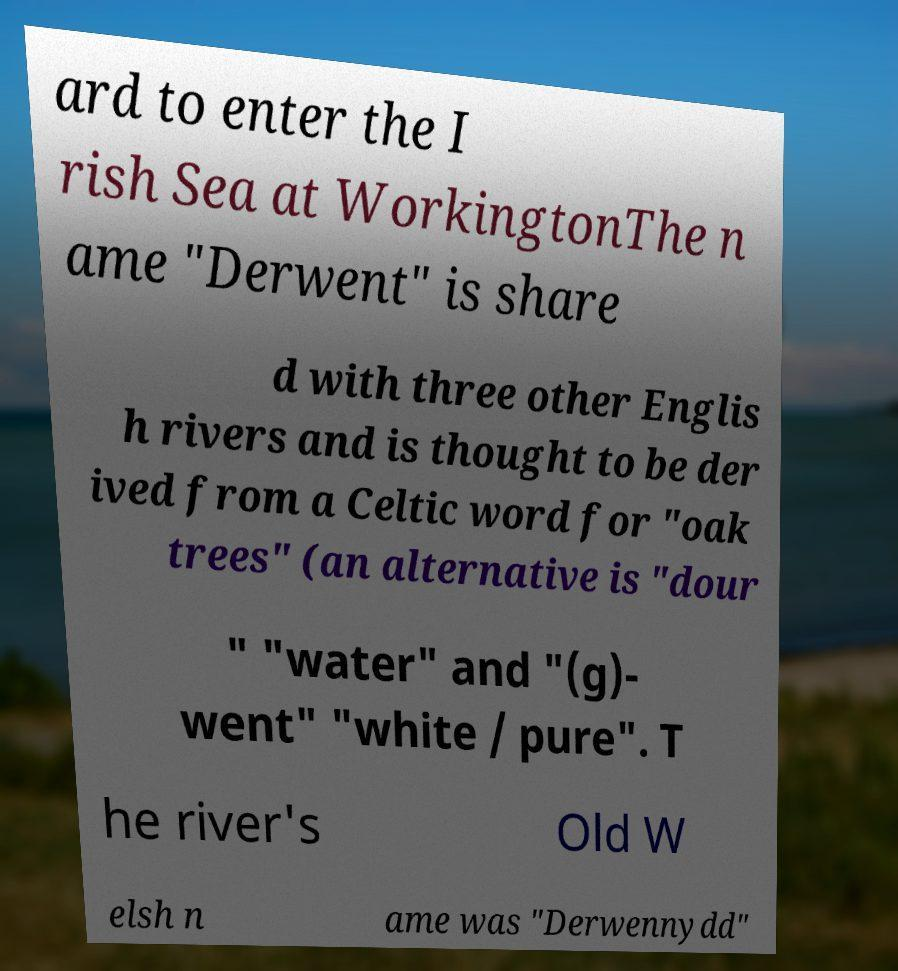Please identify and transcribe the text found in this image. ard to enter the I rish Sea at WorkingtonThe n ame "Derwent" is share d with three other Englis h rivers and is thought to be der ived from a Celtic word for "oak trees" (an alternative is "dour " "water" and "(g)- went" "white / pure". T he river's Old W elsh n ame was "Derwennydd" 